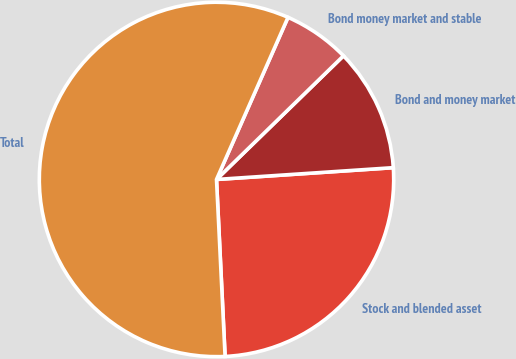Convert chart to OTSL. <chart><loc_0><loc_0><loc_500><loc_500><pie_chart><fcel>Stock and blended asset<fcel>Bond and money market<fcel>Bond money market and stable<fcel>Total<nl><fcel>25.29%<fcel>11.23%<fcel>6.1%<fcel>57.39%<nl></chart> 